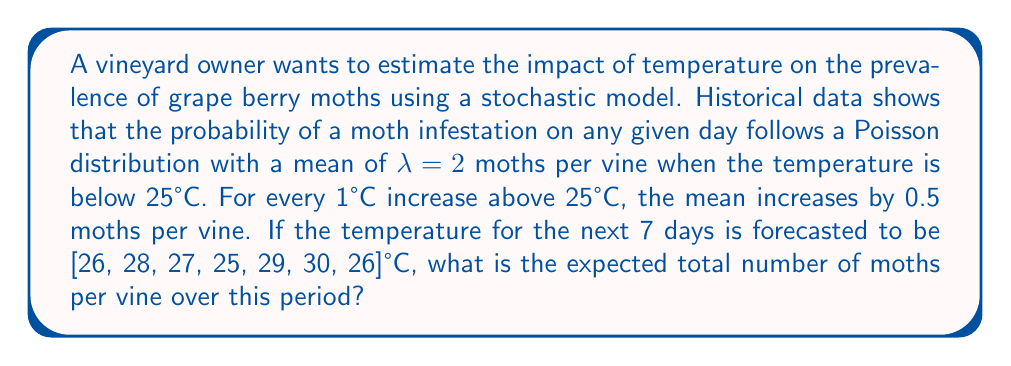Help me with this question. Let's approach this step-by-step:

1) First, we need to calculate the λ (mean) for each day based on the temperature:

   Day 1 (26°C): λ₁ = 2 + (26 - 25) * 0.5 = 2.5
   Day 2 (28°C): λ₂ = 2 + (28 - 25) * 0.5 = 3.5
   Day 3 (27°C): λ₃ = 2 + (27 - 25) * 0.5 = 3
   Day 4 (25°C): λ₄ = 2
   Day 5 (29°C): λ₅ = 2 + (29 - 25) * 0.5 = 4
   Day 6 (30°C): λ₆ = 2 + (30 - 25) * 0.5 = 4.5
   Day 7 (26°C): λ₇ = 2 + (26 - 25) * 0.5 = 2.5

2) In a Poisson distribution, the expected value (mean) is equal to λ.

3) The expected total number of moths over the 7-day period is the sum of the expected values for each day:

   $$E[Total] = \sum_{i=1}^7 \lambda_i$$

4) Substituting the values:

   $$E[Total] = 2.5 + 3.5 + 3 + 2 + 4 + 4.5 + 2.5$$

5) Calculating the sum:

   $$E[Total] = 22$$

Therefore, the expected total number of moths per vine over the 7-day period is 22.
Answer: 22 moths per vine 